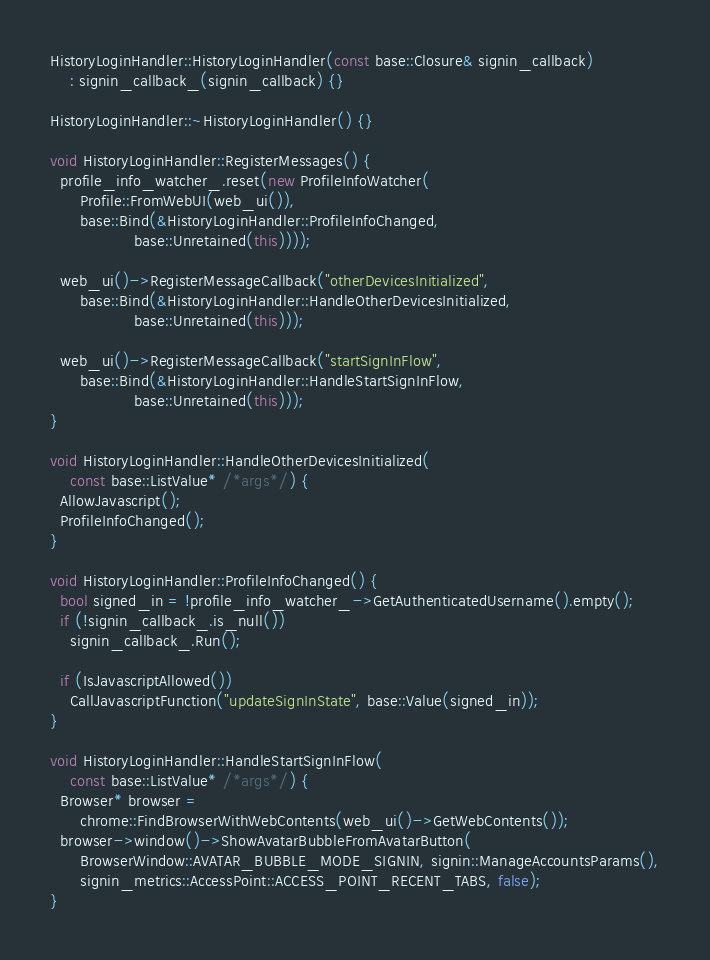Convert code to text. <code><loc_0><loc_0><loc_500><loc_500><_C++_>HistoryLoginHandler::HistoryLoginHandler(const base::Closure& signin_callback)
    : signin_callback_(signin_callback) {}

HistoryLoginHandler::~HistoryLoginHandler() {}

void HistoryLoginHandler::RegisterMessages() {
  profile_info_watcher_.reset(new ProfileInfoWatcher(
      Profile::FromWebUI(web_ui()),
      base::Bind(&HistoryLoginHandler::ProfileInfoChanged,
                 base::Unretained(this))));

  web_ui()->RegisterMessageCallback("otherDevicesInitialized",
      base::Bind(&HistoryLoginHandler::HandleOtherDevicesInitialized,
                 base::Unretained(this)));

  web_ui()->RegisterMessageCallback("startSignInFlow",
      base::Bind(&HistoryLoginHandler::HandleStartSignInFlow,
                 base::Unretained(this)));
}

void HistoryLoginHandler::HandleOtherDevicesInitialized(
    const base::ListValue* /*args*/) {
  AllowJavascript();
  ProfileInfoChanged();
}

void HistoryLoginHandler::ProfileInfoChanged() {
  bool signed_in = !profile_info_watcher_->GetAuthenticatedUsername().empty();
  if (!signin_callback_.is_null())
    signin_callback_.Run();

  if (IsJavascriptAllowed())
    CallJavascriptFunction("updateSignInState", base::Value(signed_in));
}

void HistoryLoginHandler::HandleStartSignInFlow(
    const base::ListValue* /*args*/) {
  Browser* browser =
      chrome::FindBrowserWithWebContents(web_ui()->GetWebContents());
  browser->window()->ShowAvatarBubbleFromAvatarButton(
      BrowserWindow::AVATAR_BUBBLE_MODE_SIGNIN, signin::ManageAccountsParams(),
      signin_metrics::AccessPoint::ACCESS_POINT_RECENT_TABS, false);
}
</code> 